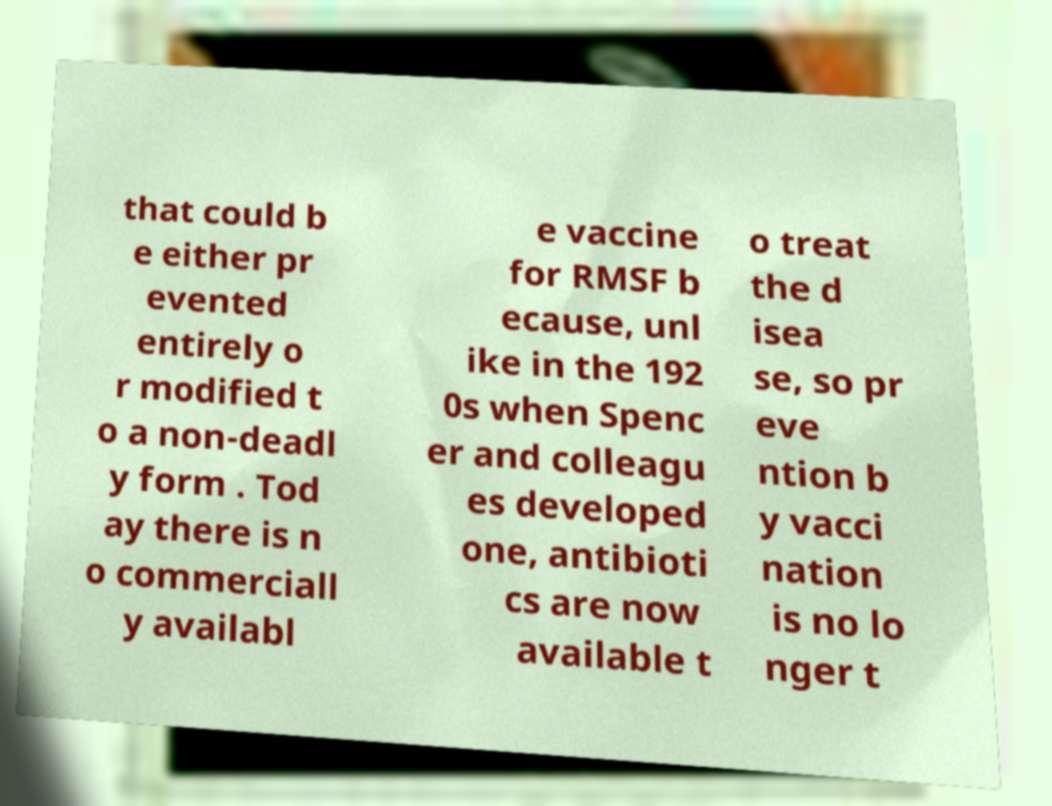There's text embedded in this image that I need extracted. Can you transcribe it verbatim? that could b e either pr evented entirely o r modified t o a non-deadl y form . Tod ay there is n o commerciall y availabl e vaccine for RMSF b ecause, unl ike in the 192 0s when Spenc er and colleagu es developed one, antibioti cs are now available t o treat the d isea se, so pr eve ntion b y vacci nation is no lo nger t 